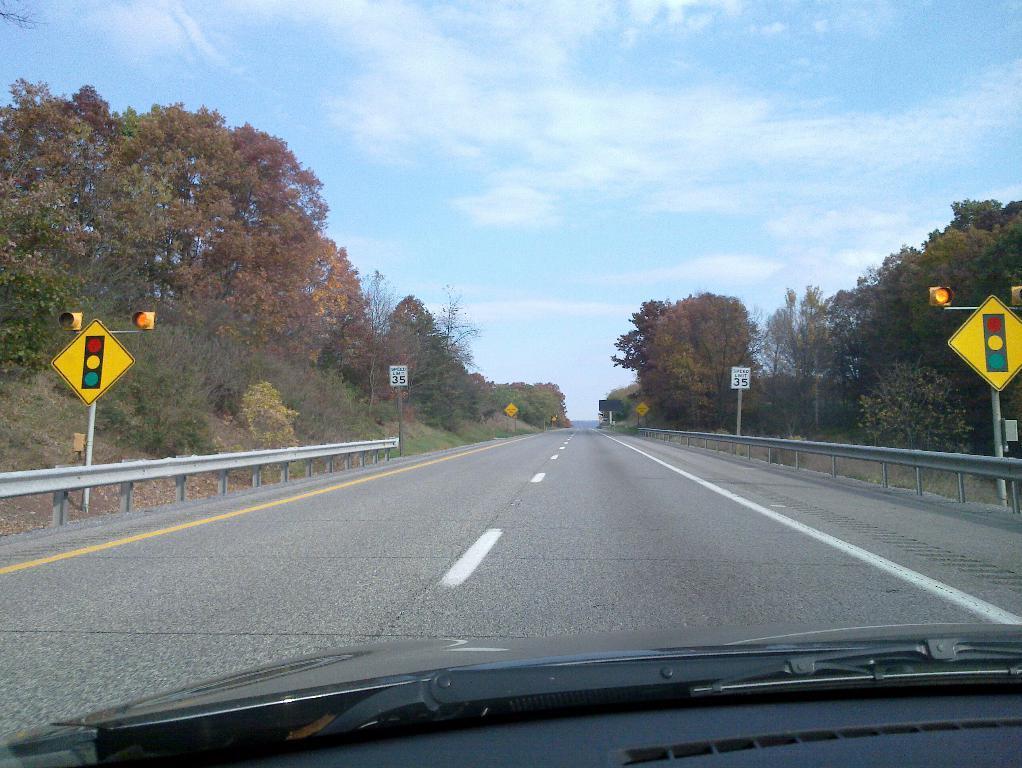Can you describe this image briefly? In this image I can see a vehicle, road, trees and poles beside the road. 